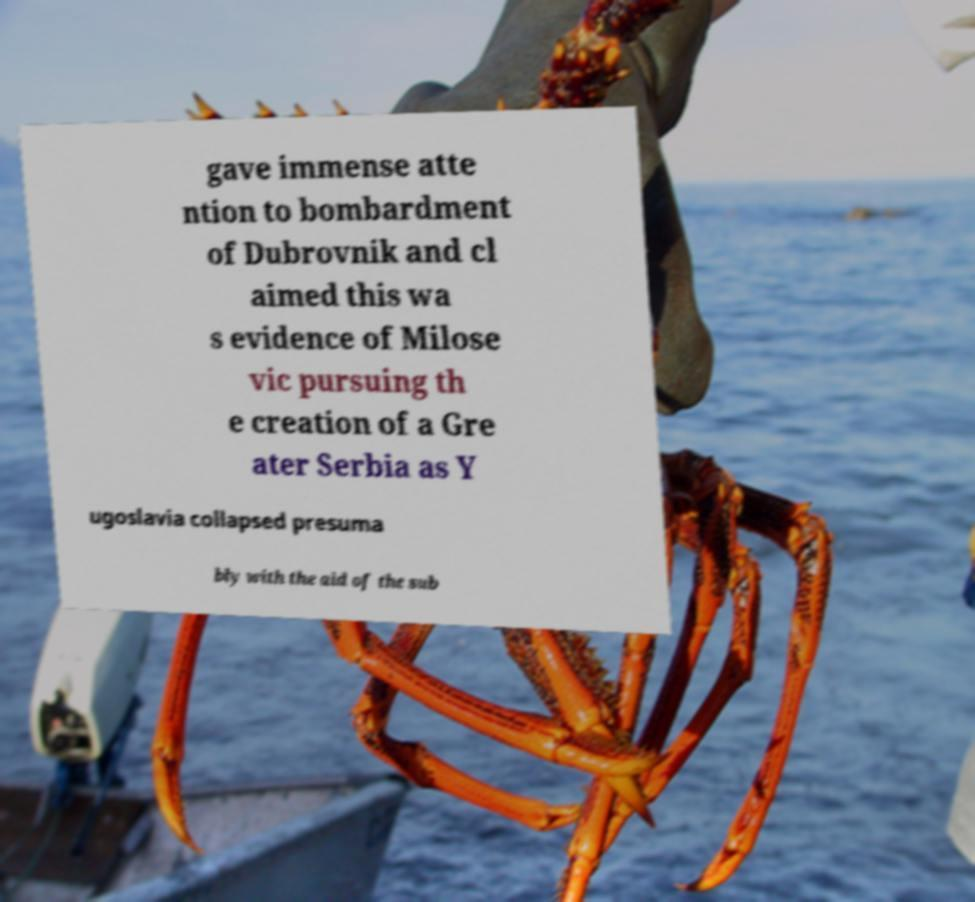There's text embedded in this image that I need extracted. Can you transcribe it verbatim? gave immense atte ntion to bombardment of Dubrovnik and cl aimed this wa s evidence of Milose vic pursuing th e creation of a Gre ater Serbia as Y ugoslavia collapsed presuma bly with the aid of the sub 